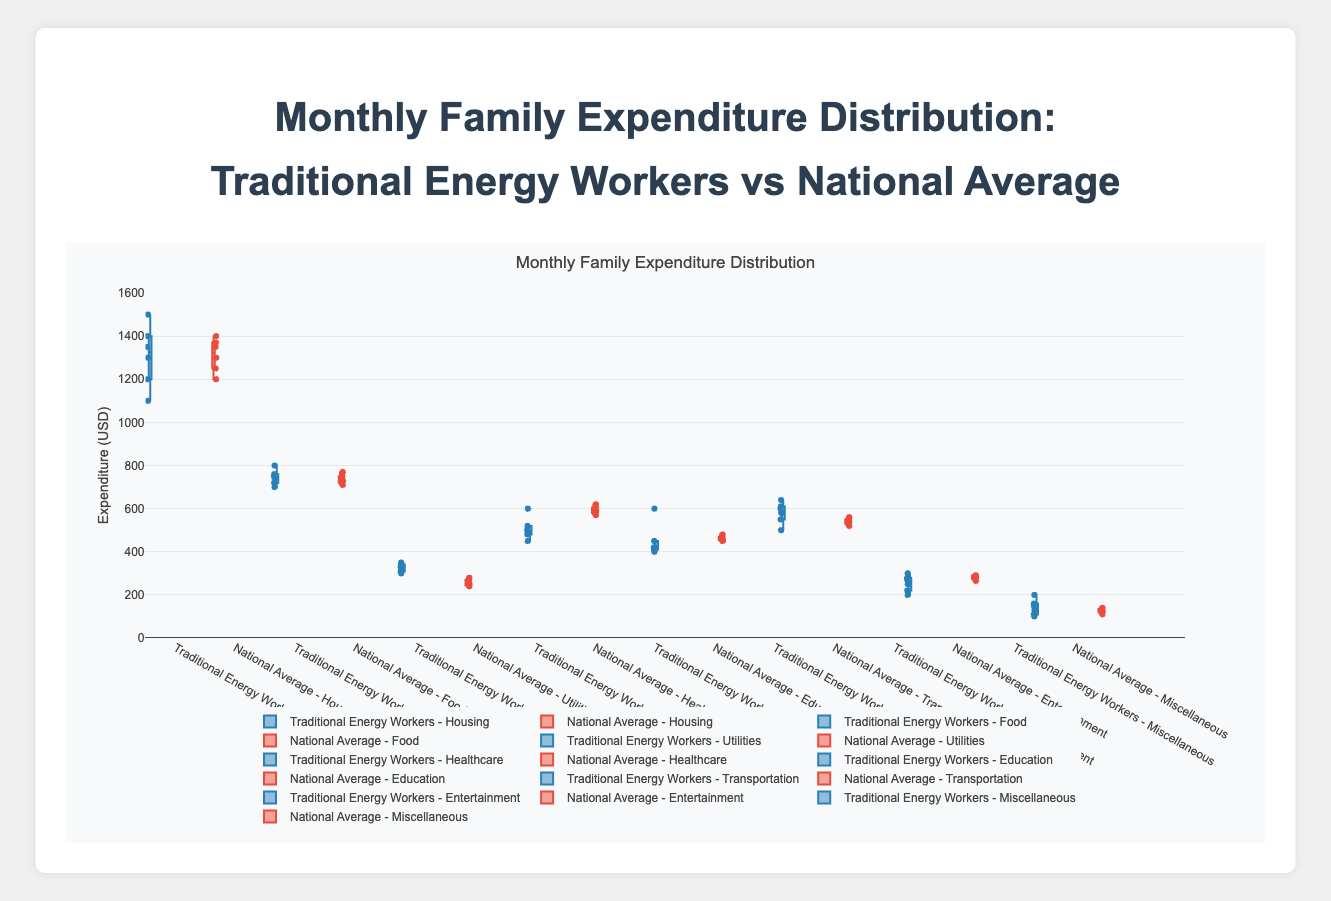What is the title of the figure? The title is often found at the top of the plot area and describes what the visualization represents. In this case, the title is "Monthly Family Expenditure Distribution: Traditional Energy Workers vs National Average".
Answer: Monthly Family Expenditure Distribution: Traditional Energy Workers vs National Average How many categories are compared in the figure? Categories in a box plot are usually represented on the x-axis. Here, each box represents a category, and there are eight categories displayed in the figure.
Answer: 8 What color represents the Traditional Energy Workers' expenditure? Colors can often be discerned from the figure legend. According to the description, the Traditional Energy Workers' expenditure is represented by the blue color (#2980b9).
Answer: Blue Which expenditure category appears to have the highest median for Traditional Energy Workers? The median of each box in a box plot is represented by the line inside the box. By visually inspecting the plot, the highest median can be identified. In this case, the Housing category has the highest median for Traditional Energy Workers.
Answer: Housing Which category shows the greatest spread in expenditure for Traditional Energy Workers? The spread in a box plot is indicated by the interquartile range (the length of the box). To determine the greatest spread, observe the category with the longest box. Here, the Housing category shows the greatest spread for Traditional Energy Workers.
Answer: Housing How does the median expenditure for healthcare compare between Traditional Energy Workers and the National Average? Compare the median values (the center lines) within the Healthcare category boxes for both groups. For Traditional Energy Workers, the median is lower than for the National Average.
Answer: Lower In which category do the Traditional Energy Workers and the National Average have roughly equal median expenditures? Find the categories where the central lines within the boxes for both groups align closely. In this case, the Food category shows roughly equal medians.
Answer: Food What is the range of expenditure for Utilities for Traditional Energy Workers? The range is the difference between the maximum and minimum values, represented by the top and bottom whiskers in the box plot. For Utilities, visually check the Traditional Energy Workers' box plot: minimum around 300 and maximum around 350.
Answer: 300 to 350 Which expenditure category has the smallest variation for the National Average? The smallest variation is indicated by the shortest box (interquartile range). Observing the plot, Utilities has the smallest box for the National Average.
Answer: Utilities 